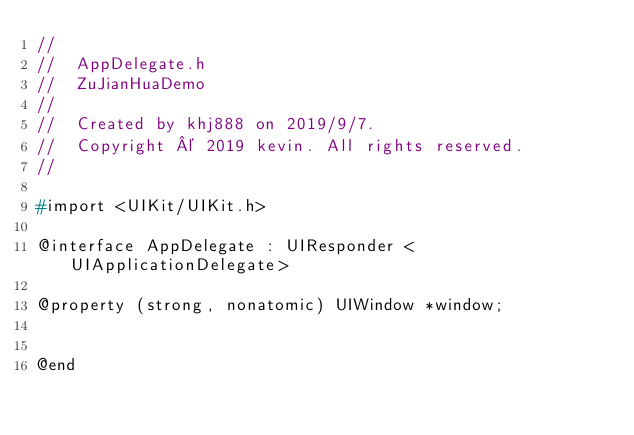Convert code to text. <code><loc_0><loc_0><loc_500><loc_500><_C_>//
//  AppDelegate.h
//  ZuJianHuaDemo
//
//  Created by khj888 on 2019/9/7.
//  Copyright © 2019 kevin. All rights reserved.
//

#import <UIKit/UIKit.h>

@interface AppDelegate : UIResponder <UIApplicationDelegate>

@property (strong, nonatomic) UIWindow *window;


@end

</code> 